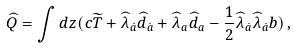<formula> <loc_0><loc_0><loc_500><loc_500>\widehat { Q } = \int d z ( c \widetilde { T } + \widehat { \lambda } _ { \dot { a } } \widehat { d } _ { \dot { a } } + \widehat { \lambda } _ { a } \widehat { d } _ { a } - \frac { 1 } { 2 } \widehat { \lambda } _ { \dot { a } } \widehat { \lambda } _ { \dot { a } } b ) \, ,</formula> 